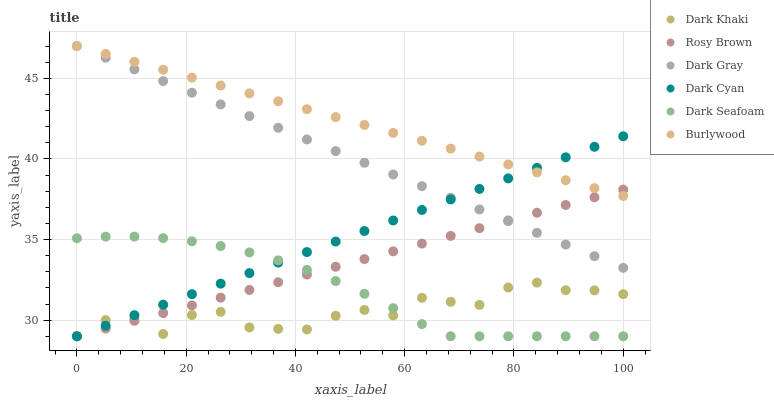Does Dark Khaki have the minimum area under the curve?
Answer yes or no. Yes. Does Burlywood have the maximum area under the curve?
Answer yes or no. Yes. Does Rosy Brown have the minimum area under the curve?
Answer yes or no. No. Does Rosy Brown have the maximum area under the curve?
Answer yes or no. No. Is Burlywood the smoothest?
Answer yes or no. Yes. Is Dark Khaki the roughest?
Answer yes or no. Yes. Is Rosy Brown the smoothest?
Answer yes or no. No. Is Rosy Brown the roughest?
Answer yes or no. No. Does Rosy Brown have the lowest value?
Answer yes or no. Yes. Does Burlywood have the lowest value?
Answer yes or no. No. Does Burlywood have the highest value?
Answer yes or no. Yes. Does Rosy Brown have the highest value?
Answer yes or no. No. Is Dark Seafoam less than Burlywood?
Answer yes or no. Yes. Is Burlywood greater than Dark Seafoam?
Answer yes or no. Yes. Does Dark Gray intersect Rosy Brown?
Answer yes or no. Yes. Is Dark Gray less than Rosy Brown?
Answer yes or no. No. Is Dark Gray greater than Rosy Brown?
Answer yes or no. No. Does Dark Seafoam intersect Burlywood?
Answer yes or no. No. 